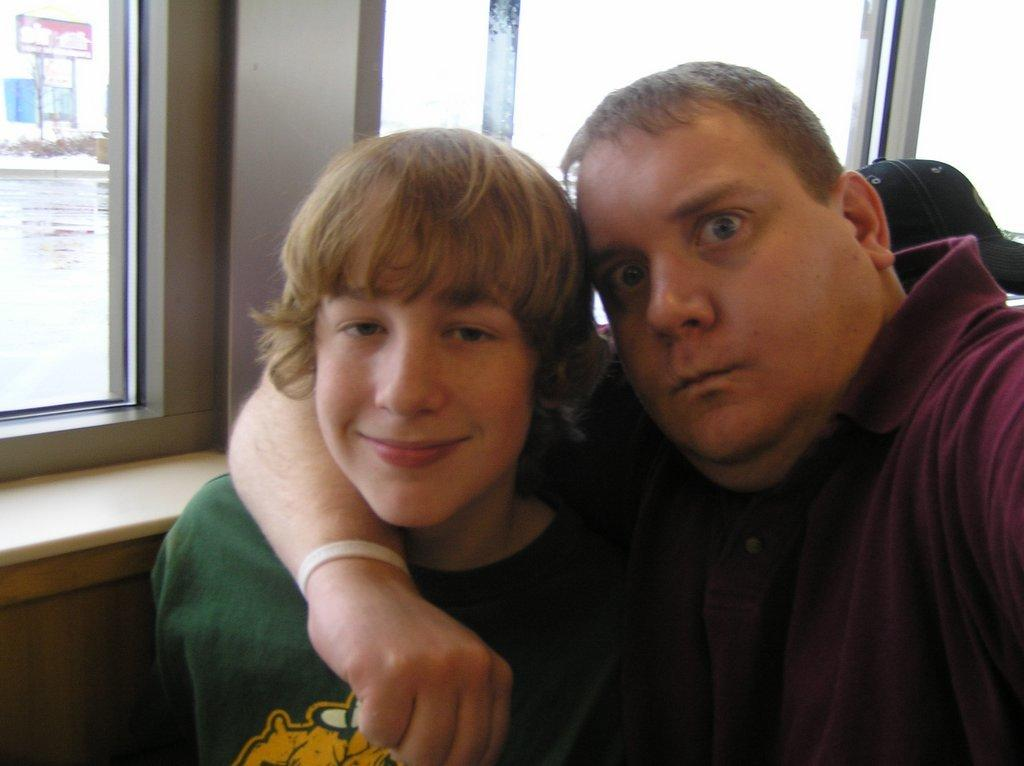Who are the people in the image? There is a man and a boy in the image. What can be seen in the background of the image? There are windows in the background of the image. What is visible through the windows? Water and other items are visible through the windows. What shape is the grass in the image? There is no grass present in the image, so it is not possible to determine its shape. 